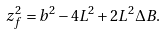Convert formula to latex. <formula><loc_0><loc_0><loc_500><loc_500>z _ { f } ^ { 2 } = b ^ { 2 } - 4 L ^ { 2 } + 2 L ^ { 2 } \Delta B .</formula> 